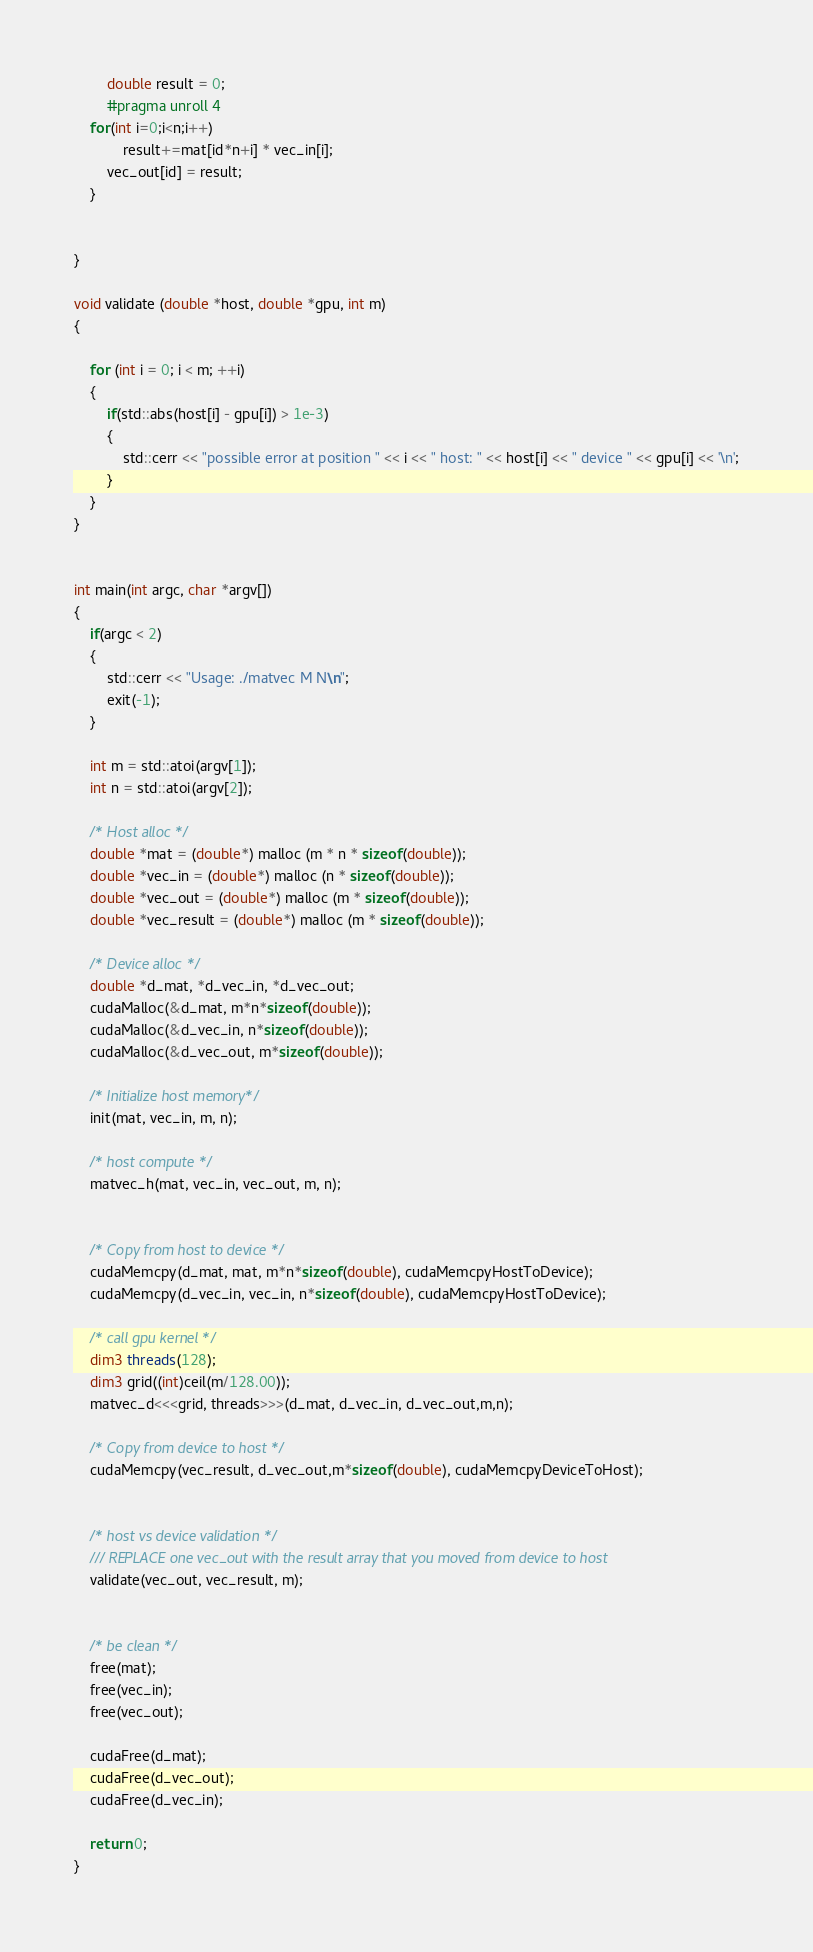Convert code to text. <code><loc_0><loc_0><loc_500><loc_500><_Cuda_>        double result = 0;
        #pragma unroll 4 
	for(int i=0;i<n;i++)
        	result+=mat[id*n+i] * vec_in[i];
        vec_out[id] = result;
    }


}

void validate (double *host, double *gpu, int m)
{

    for (int i = 0; i < m; ++i)
    {
        if(std::abs(host[i] - gpu[i]) > 1e-3)
        {
            std::cerr << "possible error at position " << i << " host: " << host[i] << " device " << gpu[i] << '\n';
        }
    }
}


int main(int argc, char *argv[])
{
    if(argc < 2)
    {
        std::cerr << "Usage: ./matvec M N\n";
        exit(-1);
    }

    int m = std::atoi(argv[1]);
    int n = std::atoi(argv[2]);

    /* Host alloc */
    double *mat = (double*) malloc (m * n * sizeof(double));
    double *vec_in = (double*) malloc (n * sizeof(double));
    double *vec_out = (double*) malloc (m * sizeof(double));
    double *vec_result = (double*) malloc (m * sizeof(double));

    /* Device alloc */
    double *d_mat, *d_vec_in, *d_vec_out;
    cudaMalloc(&d_mat, m*n*sizeof(double));
    cudaMalloc(&d_vec_in, n*sizeof(double));
    cudaMalloc(&d_vec_out, m*sizeof(double));

    /* Initialize host memory*/
    init(mat, vec_in, m, n);

    /* host compute */
    matvec_h(mat, vec_in, vec_out, m, n);


    /* Copy from host to device */
    cudaMemcpy(d_mat, mat, m*n*sizeof(double), cudaMemcpyHostToDevice);
    cudaMemcpy(d_vec_in, vec_in, n*sizeof(double), cudaMemcpyHostToDevice);

    /* call gpu kernel */
    dim3 threads(128);
    dim3 grid((int)ceil(m/128.00));    
    matvec_d<<<grid, threads>>>(d_mat, d_vec_in, d_vec_out,m,n);

    /* Copy from device to host */
    cudaMemcpy(vec_result, d_vec_out,m*sizeof(double), cudaMemcpyDeviceToHost); 


    /* host vs device validation */
    /// REPLACE one vec_out with the result array that you moved from device to host
    validate(vec_out, vec_result, m);


    /* be clean */
    free(mat);
    free(vec_in);
    free(vec_out);

    cudaFree(d_mat);
    cudaFree(d_vec_out);
    cudaFree(d_vec_in);

    return 0;
}




</code> 